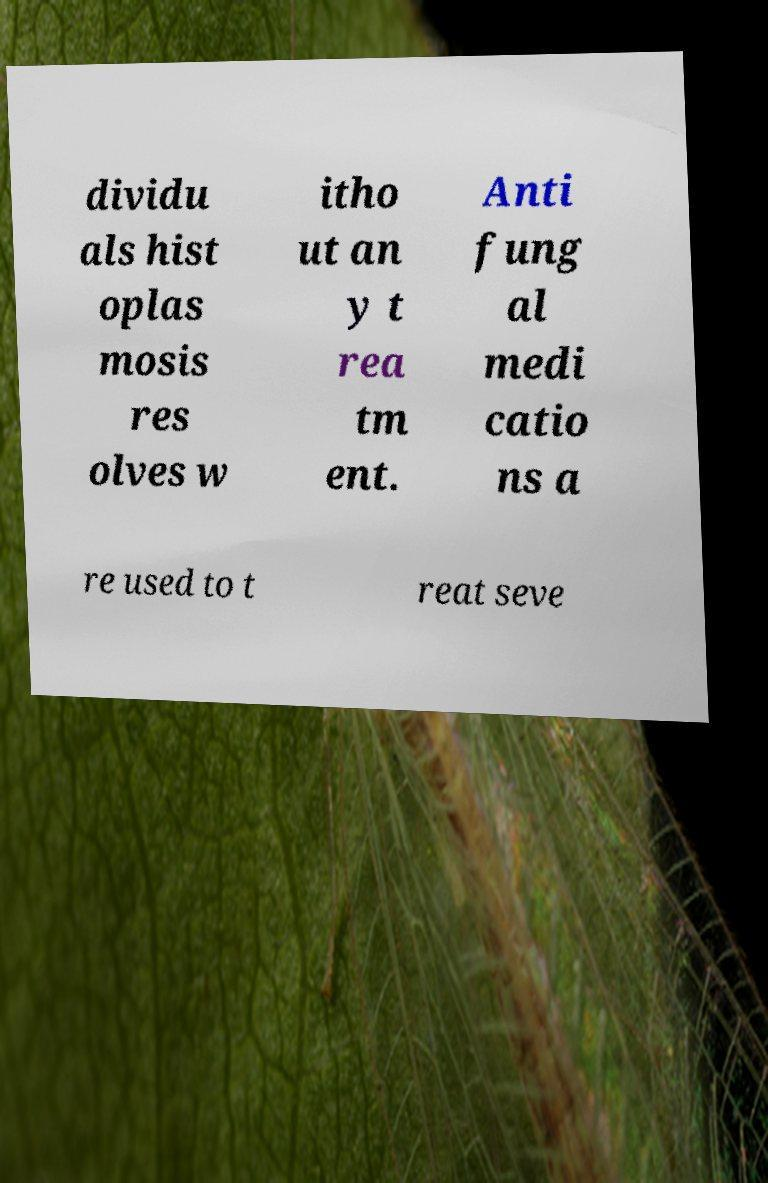I need the written content from this picture converted into text. Can you do that? dividu als hist oplas mosis res olves w itho ut an y t rea tm ent. Anti fung al medi catio ns a re used to t reat seve 